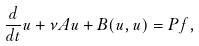<formula> <loc_0><loc_0><loc_500><loc_500>\frac { d } { d t } u + \nu A u + B ( u , u ) = P f ,</formula> 